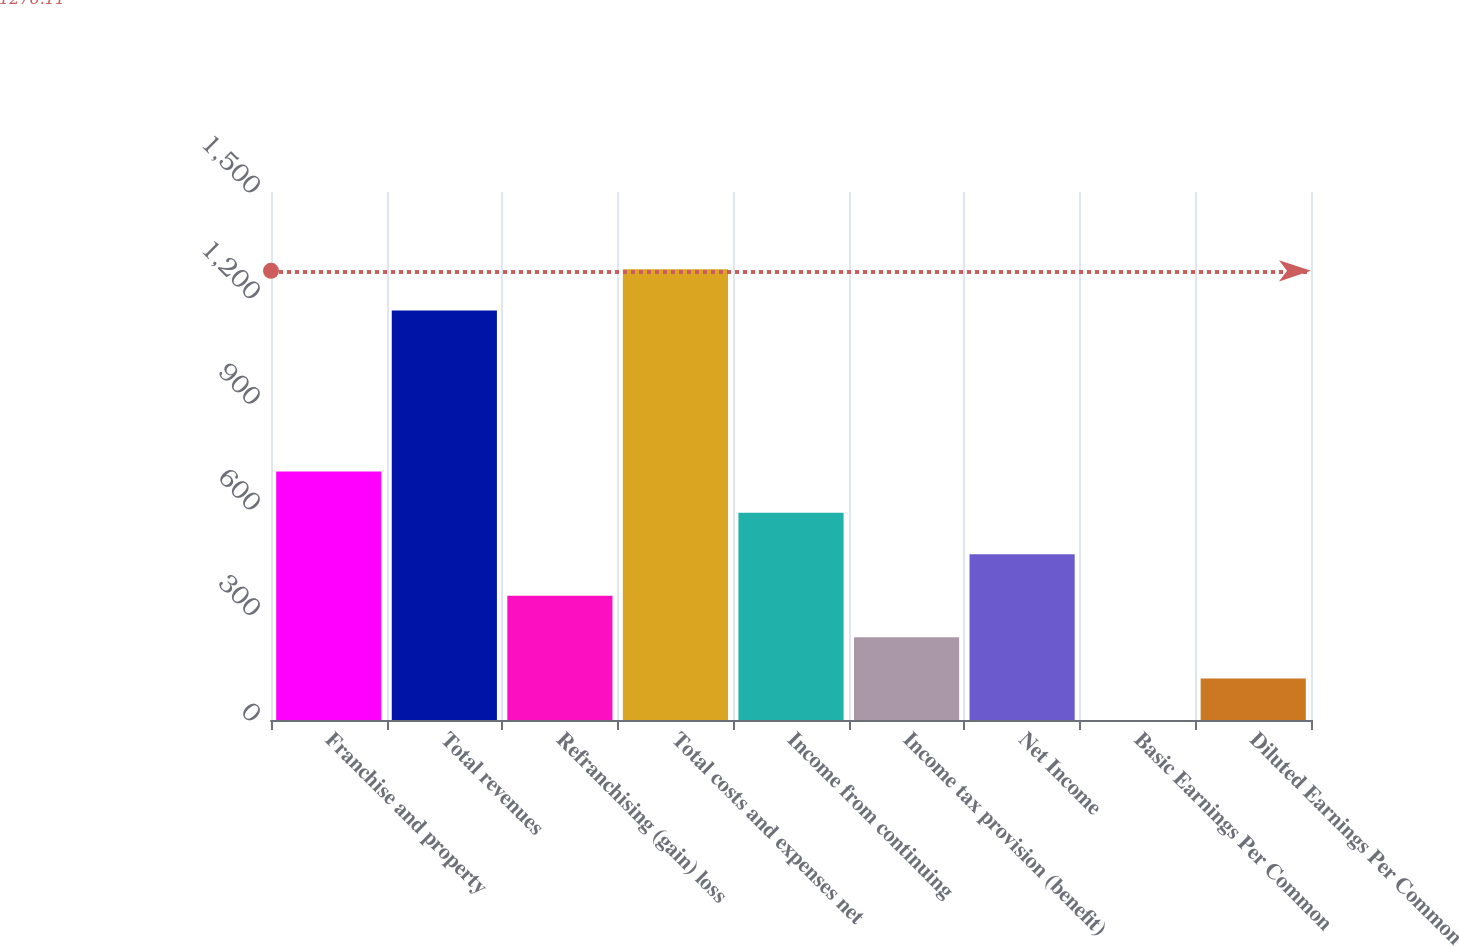<chart> <loc_0><loc_0><loc_500><loc_500><bar_chart><fcel>Franchise and property<fcel>Total revenues<fcel>Refranchising (gain) loss<fcel>Total costs and expenses net<fcel>Income from continuing<fcel>Income tax provision (benefit)<fcel>Net Income<fcel>Basic Earnings Per Common<fcel>Diluted Earnings Per Common<nl><fcel>706.23<fcel>1163<fcel>353.13<fcel>1280.7<fcel>588.53<fcel>235.43<fcel>470.83<fcel>0.03<fcel>117.73<nl></chart> 